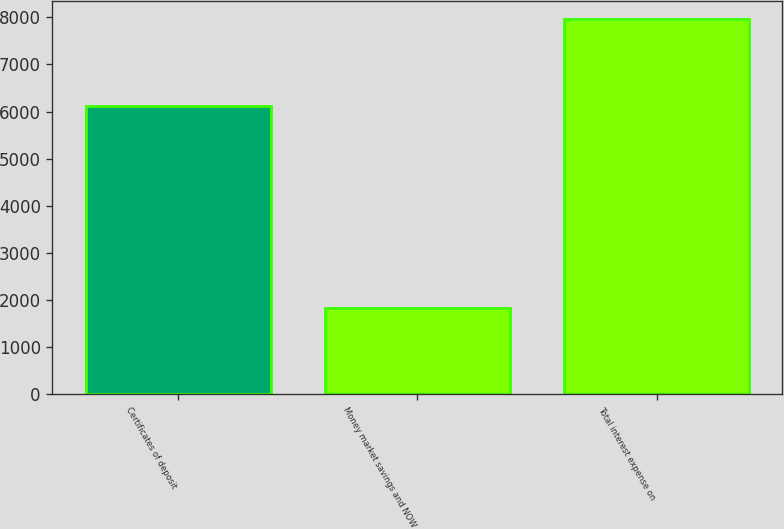Convert chart to OTSL. <chart><loc_0><loc_0><loc_500><loc_500><bar_chart><fcel>Certificates of deposit<fcel>Money market savings and NOW<fcel>Total interest expense on<nl><fcel>6126<fcel>1833<fcel>7959<nl></chart> 